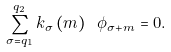<formula> <loc_0><loc_0><loc_500><loc_500>\sum _ { \sigma = q _ { 1 } } ^ { q _ { 2 } } k _ { \sigma } \left ( m \right ) \ \phi _ { \sigma + m } = 0 .</formula> 